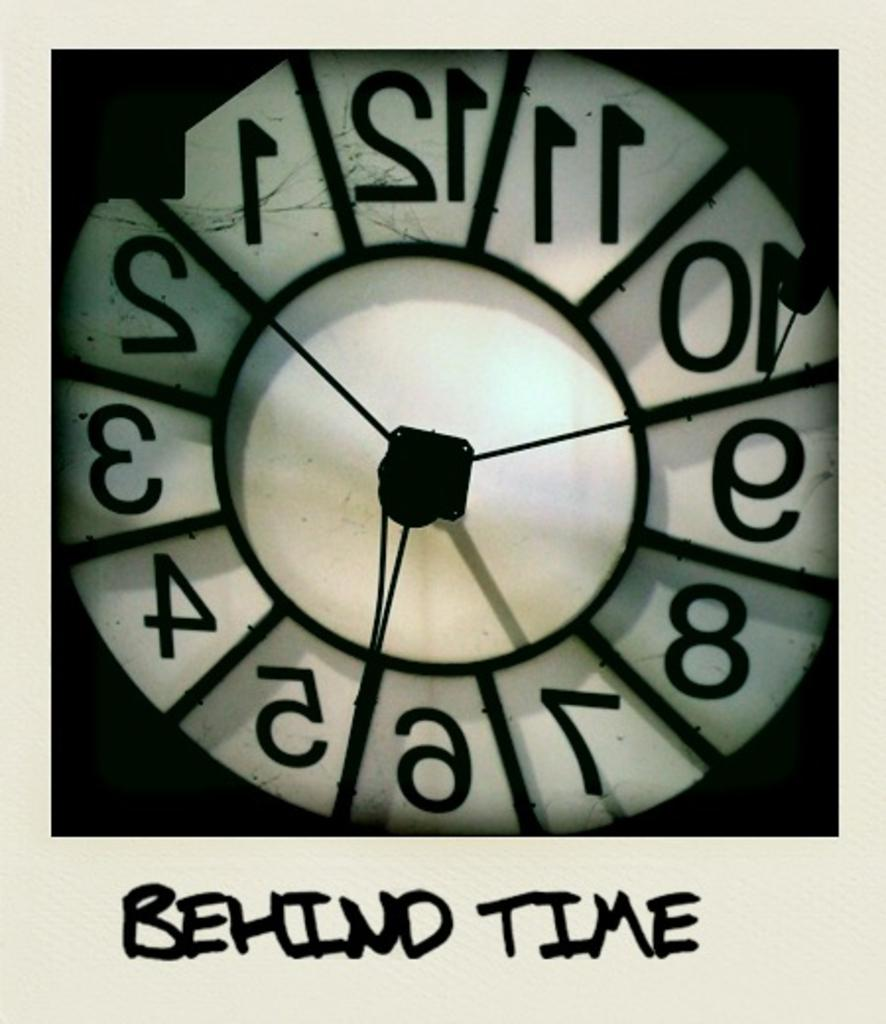<image>
Create a compact narrative representing the image presented. behind time is written below the clock that is white 